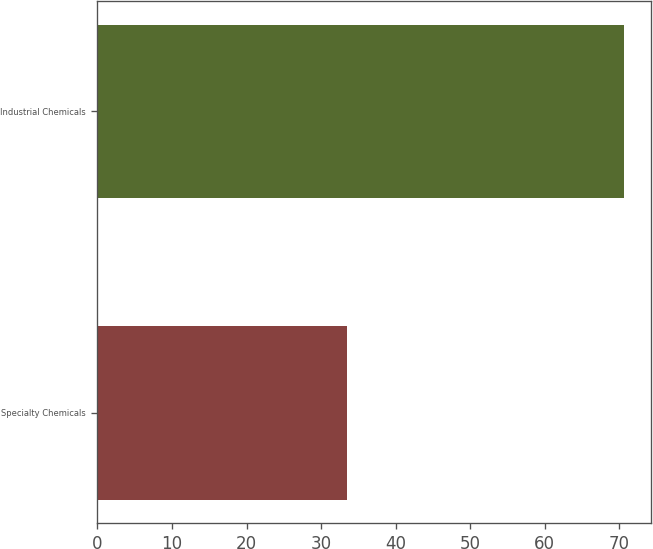Convert chart. <chart><loc_0><loc_0><loc_500><loc_500><bar_chart><fcel>Specialty Chemicals<fcel>Industrial Chemicals<nl><fcel>33.5<fcel>70.7<nl></chart> 